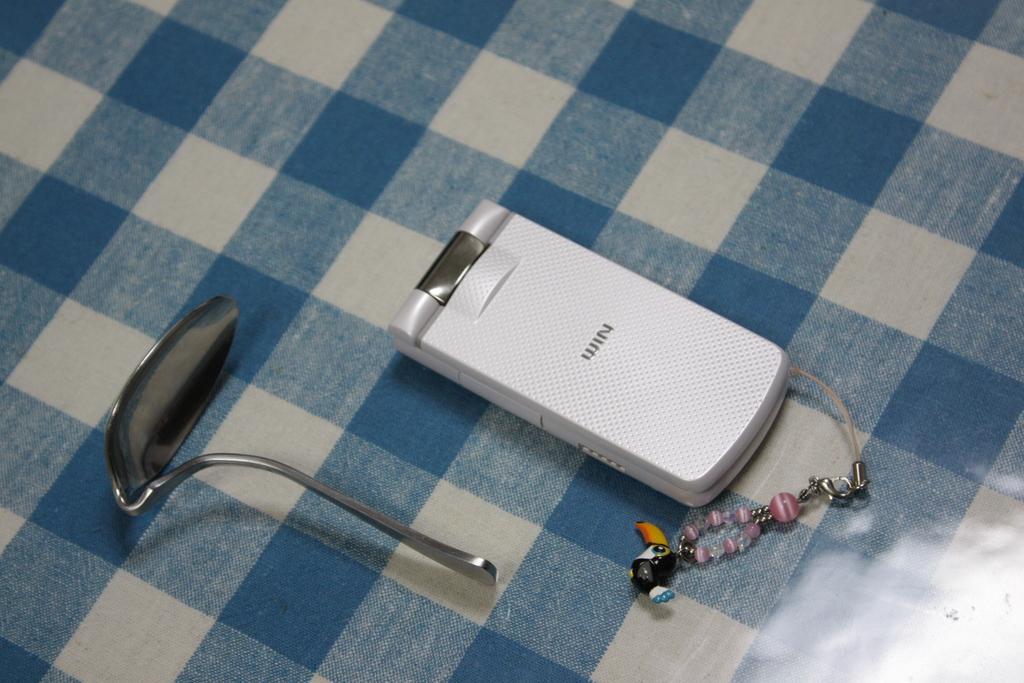Describe this image in one or two sentences. In this image we can see a mobile phone with key chain and a bent spoon kept on the cloth which is in blue and white color. 